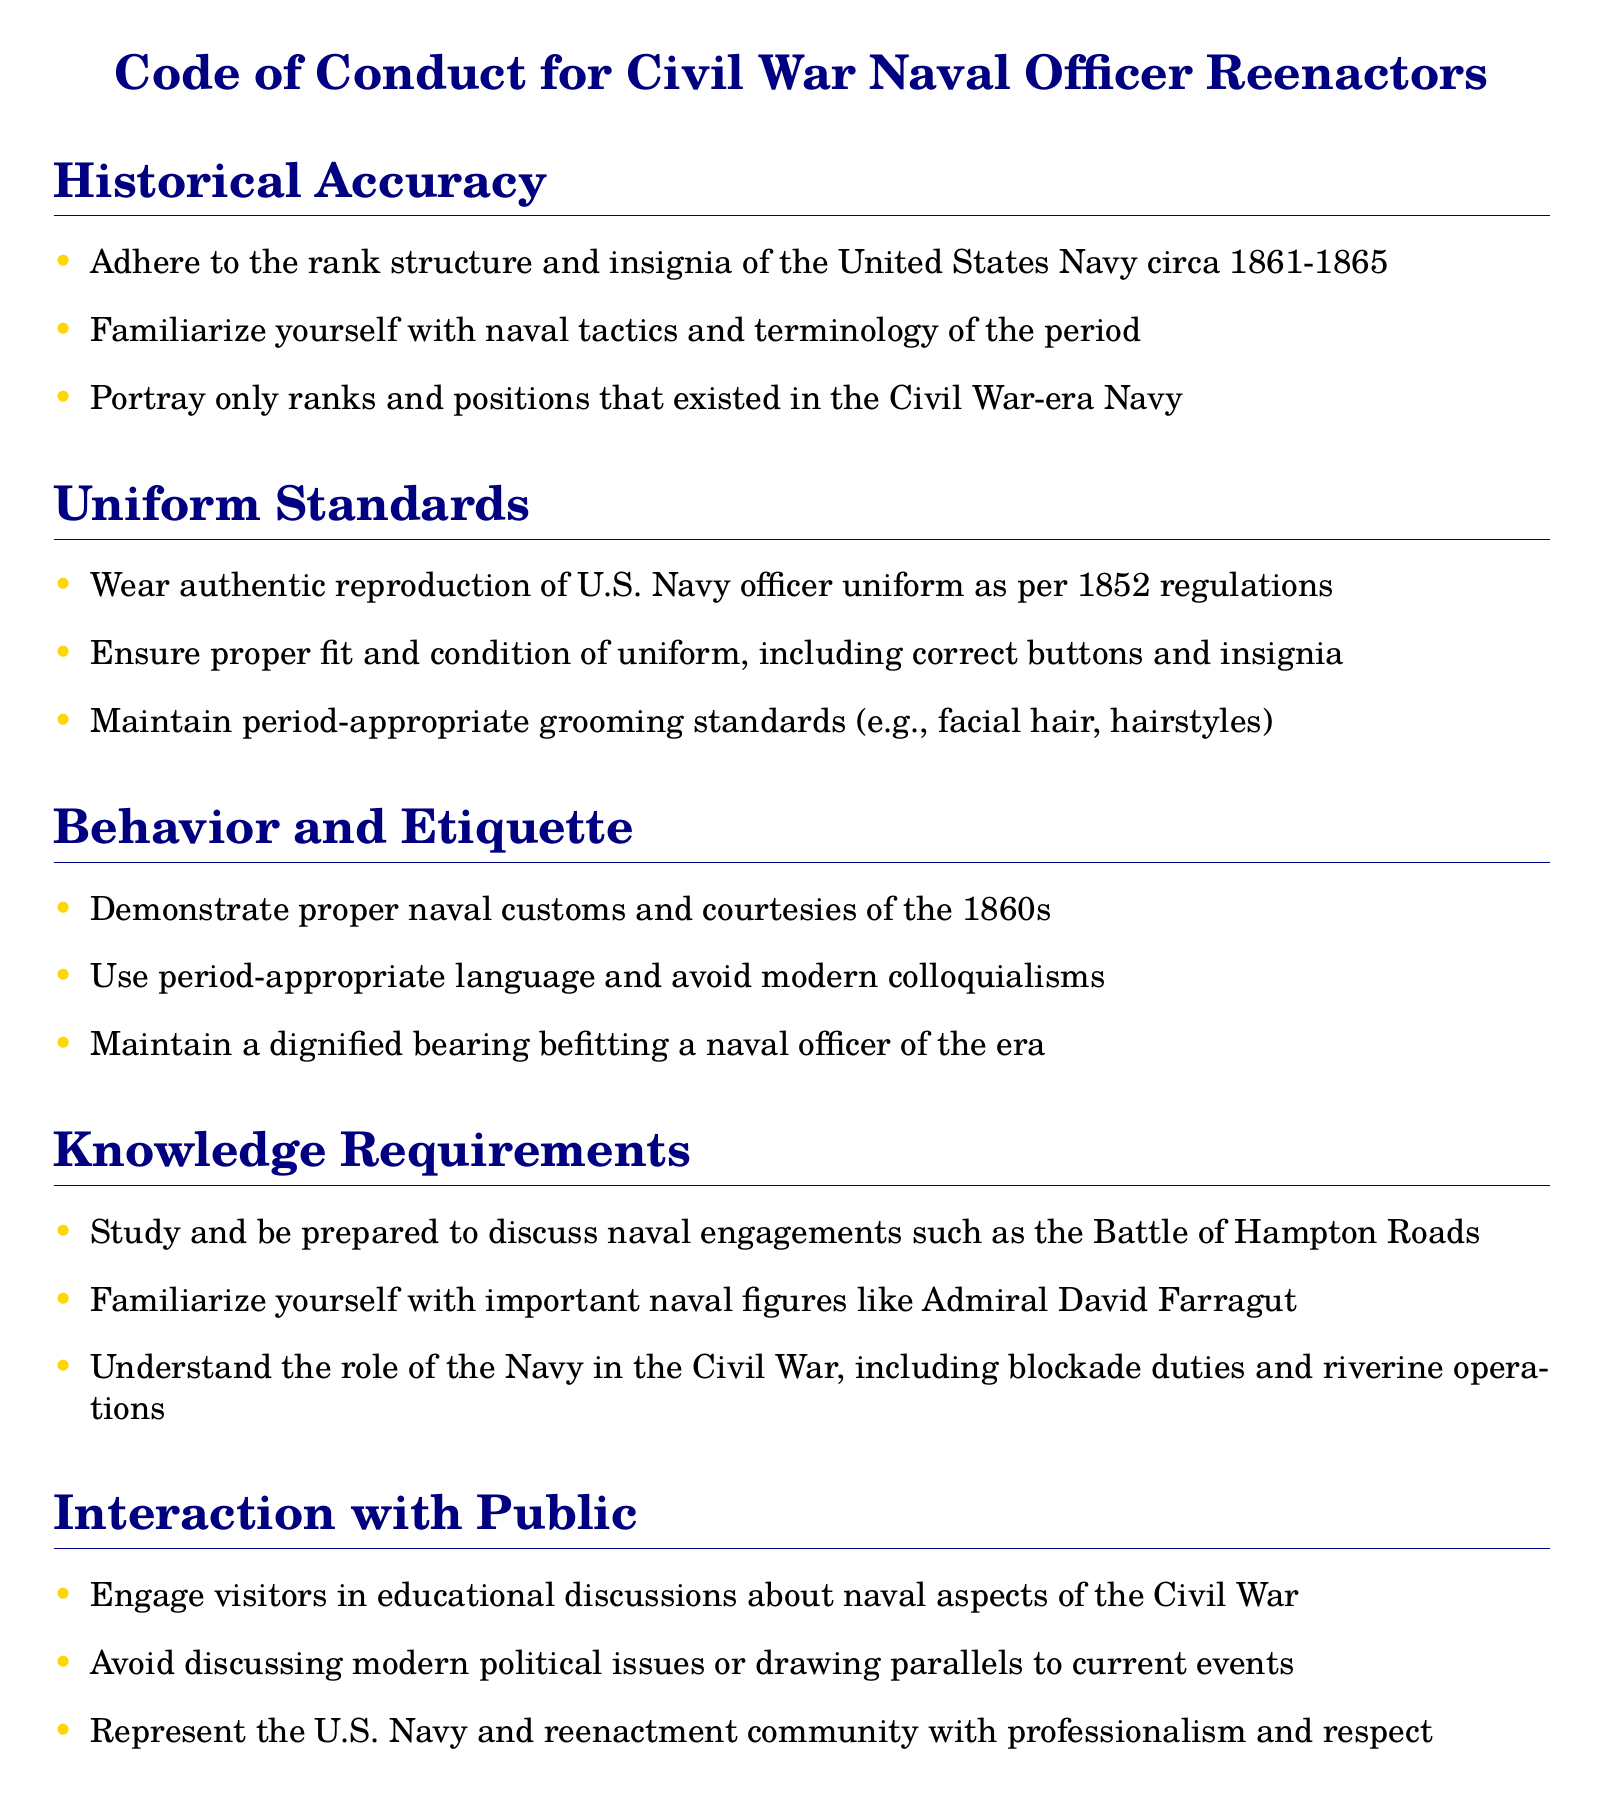What is the uniform standard year? The document specifies the uniform standard should adhere to 1852 regulations.
Answer: 1852 Who is an important naval figure mentioned? The document lists Admiral David Farragut as an important naval figure.
Answer: Admiral David Farragut What should you avoid in public discussions? The code advises against discussing modern political issues.
Answer: Modern political issues What kind of uniforms should be worn? The document indicates that reenactors should wear authentic reproductions of U.S. Navy officer uniforms.
Answer: Authentic reproduction How should period-appropriate grooming be maintained? The document mentions grooming standards including facial hair and hairstyles appropriate for the era.
Answer: Facial hair, hairstyles How should one behave at events? The code states that reenactors must maintain a dignified bearing befitting a naval officer of the era.
Answer: Dignified bearing What are reenactors expected to study? The document requires reenactors to study and be prepared to discuss naval engagements such as the Battle of Hampton Roads.
Answer: Naval engagements What type of language should be used? The policy states that period-appropriate language should be used, avoiding modern colloquialisms.
Answer: Period-appropriate language What should be familiarized regarding naval tactics? The document specifies that reenactors should familiarize themselves with naval tactics and terminology of the period.
Answer: Naval tactics and terminology 